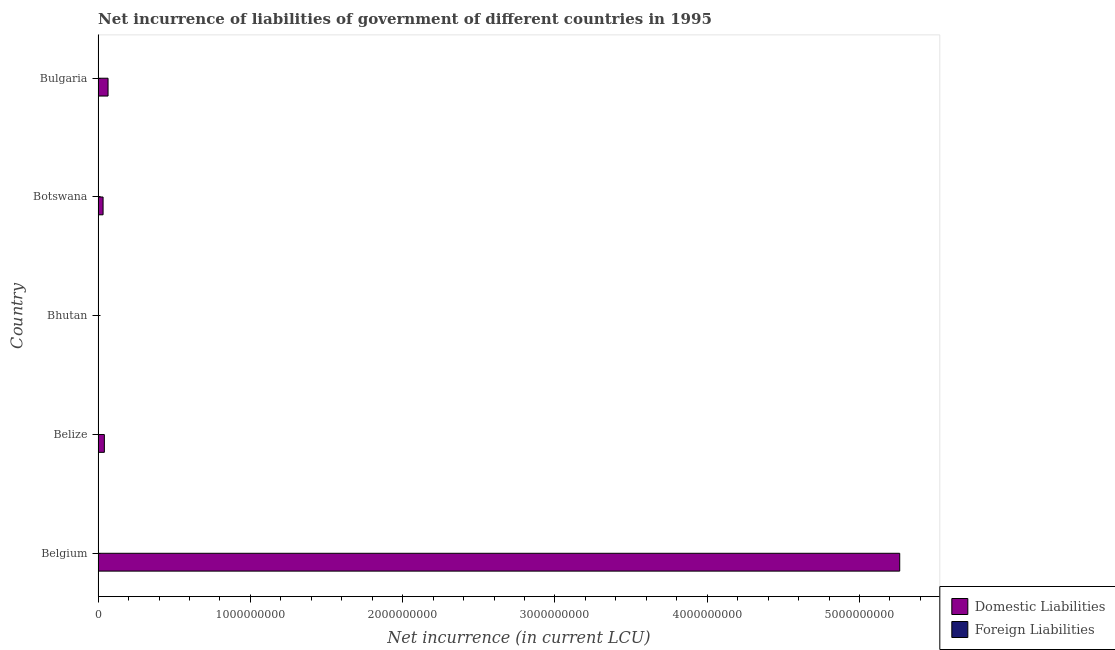How many different coloured bars are there?
Keep it short and to the point. 1. Are the number of bars per tick equal to the number of legend labels?
Your answer should be compact. No. How many bars are there on the 1st tick from the bottom?
Provide a short and direct response. 1. What is the label of the 2nd group of bars from the top?
Make the answer very short. Botswana. In how many cases, is the number of bars for a given country not equal to the number of legend labels?
Your response must be concise. 5. Across all countries, what is the maximum net incurrence of domestic liabilities?
Give a very brief answer. 5.26e+09. Across all countries, what is the minimum net incurrence of domestic liabilities?
Provide a short and direct response. 2.50e+06. In which country was the net incurrence of domestic liabilities maximum?
Offer a terse response. Belgium. What is the total net incurrence of foreign liabilities in the graph?
Provide a short and direct response. 0. What is the difference between the net incurrence of domestic liabilities in Botswana and that in Bulgaria?
Your answer should be compact. -3.27e+07. What is the difference between the net incurrence of foreign liabilities in Bulgaria and the net incurrence of domestic liabilities in Belize?
Provide a short and direct response. -4.12e+07. What is the average net incurrence of foreign liabilities per country?
Ensure brevity in your answer.  0. In how many countries, is the net incurrence of domestic liabilities greater than 3200000000 LCU?
Make the answer very short. 1. What is the ratio of the net incurrence of domestic liabilities in Belgium to that in Bulgaria?
Your answer should be very brief. 80.42. Is the net incurrence of domestic liabilities in Bhutan less than that in Bulgaria?
Your answer should be very brief. Yes. What is the difference between the highest and the second highest net incurrence of domestic liabilities?
Ensure brevity in your answer.  5.20e+09. What is the difference between the highest and the lowest net incurrence of domestic liabilities?
Provide a succinct answer. 5.26e+09. Is the sum of the net incurrence of domestic liabilities in Belgium and Bulgaria greater than the maximum net incurrence of foreign liabilities across all countries?
Provide a succinct answer. Yes. How many bars are there?
Provide a short and direct response. 5. Are the values on the major ticks of X-axis written in scientific E-notation?
Offer a terse response. No. How many legend labels are there?
Make the answer very short. 2. What is the title of the graph?
Your response must be concise. Net incurrence of liabilities of government of different countries in 1995. What is the label or title of the X-axis?
Your response must be concise. Net incurrence (in current LCU). What is the label or title of the Y-axis?
Provide a short and direct response. Country. What is the Net incurrence (in current LCU) in Domestic Liabilities in Belgium?
Your answer should be very brief. 5.26e+09. What is the Net incurrence (in current LCU) in Foreign Liabilities in Belgium?
Ensure brevity in your answer.  0. What is the Net incurrence (in current LCU) of Domestic Liabilities in Belize?
Keep it short and to the point. 4.12e+07. What is the Net incurrence (in current LCU) of Domestic Liabilities in Bhutan?
Ensure brevity in your answer.  2.50e+06. What is the Net incurrence (in current LCU) of Domestic Liabilities in Botswana?
Offer a terse response. 3.28e+07. What is the Net incurrence (in current LCU) of Foreign Liabilities in Botswana?
Offer a very short reply. 0. What is the Net incurrence (in current LCU) of Domestic Liabilities in Bulgaria?
Ensure brevity in your answer.  6.55e+07. Across all countries, what is the maximum Net incurrence (in current LCU) of Domestic Liabilities?
Ensure brevity in your answer.  5.26e+09. Across all countries, what is the minimum Net incurrence (in current LCU) in Domestic Liabilities?
Make the answer very short. 2.50e+06. What is the total Net incurrence (in current LCU) in Domestic Liabilities in the graph?
Your answer should be very brief. 5.41e+09. What is the total Net incurrence (in current LCU) in Foreign Liabilities in the graph?
Keep it short and to the point. 0. What is the difference between the Net incurrence (in current LCU) of Domestic Liabilities in Belgium and that in Belize?
Keep it short and to the point. 5.22e+09. What is the difference between the Net incurrence (in current LCU) of Domestic Liabilities in Belgium and that in Bhutan?
Provide a short and direct response. 5.26e+09. What is the difference between the Net incurrence (in current LCU) in Domestic Liabilities in Belgium and that in Botswana?
Offer a very short reply. 5.23e+09. What is the difference between the Net incurrence (in current LCU) of Domestic Liabilities in Belgium and that in Bulgaria?
Ensure brevity in your answer.  5.20e+09. What is the difference between the Net incurrence (in current LCU) in Domestic Liabilities in Belize and that in Bhutan?
Your response must be concise. 3.87e+07. What is the difference between the Net incurrence (in current LCU) in Domestic Liabilities in Belize and that in Botswana?
Offer a terse response. 8.44e+06. What is the difference between the Net incurrence (in current LCU) in Domestic Liabilities in Belize and that in Bulgaria?
Your response must be concise. -2.42e+07. What is the difference between the Net incurrence (in current LCU) of Domestic Liabilities in Bhutan and that in Botswana?
Give a very brief answer. -3.03e+07. What is the difference between the Net incurrence (in current LCU) of Domestic Liabilities in Bhutan and that in Bulgaria?
Your answer should be very brief. -6.30e+07. What is the difference between the Net incurrence (in current LCU) of Domestic Liabilities in Botswana and that in Bulgaria?
Make the answer very short. -3.27e+07. What is the average Net incurrence (in current LCU) of Domestic Liabilities per country?
Provide a succinct answer. 1.08e+09. What is the average Net incurrence (in current LCU) of Foreign Liabilities per country?
Your answer should be compact. 0. What is the ratio of the Net incurrence (in current LCU) of Domestic Liabilities in Belgium to that in Belize?
Provide a short and direct response. 127.65. What is the ratio of the Net incurrence (in current LCU) in Domestic Liabilities in Belgium to that in Bhutan?
Ensure brevity in your answer.  2105.61. What is the ratio of the Net incurrence (in current LCU) in Domestic Liabilities in Belgium to that in Botswana?
Offer a terse response. 160.49. What is the ratio of the Net incurrence (in current LCU) in Domestic Liabilities in Belgium to that in Bulgaria?
Provide a short and direct response. 80.42. What is the ratio of the Net incurrence (in current LCU) of Domestic Liabilities in Belize to that in Bhutan?
Provide a short and direct response. 16.5. What is the ratio of the Net incurrence (in current LCU) in Domestic Liabilities in Belize to that in Botswana?
Provide a succinct answer. 1.26. What is the ratio of the Net incurrence (in current LCU) of Domestic Liabilities in Belize to that in Bulgaria?
Ensure brevity in your answer.  0.63. What is the ratio of the Net incurrence (in current LCU) of Domestic Liabilities in Bhutan to that in Botswana?
Offer a very short reply. 0.08. What is the ratio of the Net incurrence (in current LCU) in Domestic Liabilities in Bhutan to that in Bulgaria?
Provide a short and direct response. 0.04. What is the ratio of the Net incurrence (in current LCU) of Domestic Liabilities in Botswana to that in Bulgaria?
Your answer should be very brief. 0.5. What is the difference between the highest and the second highest Net incurrence (in current LCU) in Domestic Liabilities?
Provide a succinct answer. 5.20e+09. What is the difference between the highest and the lowest Net incurrence (in current LCU) of Domestic Liabilities?
Make the answer very short. 5.26e+09. 